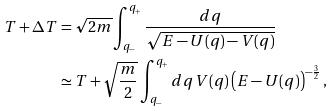Convert formula to latex. <formula><loc_0><loc_0><loc_500><loc_500>T + \Delta T & = \sqrt { 2 m } \int _ { q _ { - } } ^ { q _ { + } } \frac { d q } { \sqrt { E - U ( q ) - V ( q ) } } \\ & \simeq T + \sqrt { \frac { m } { 2 } } \int _ { q _ { - } } ^ { q _ { + } } d q \, V ( q ) \left ( E - U ( q ) \right ) ^ { - \frac { 3 } { 2 } } ,</formula> 